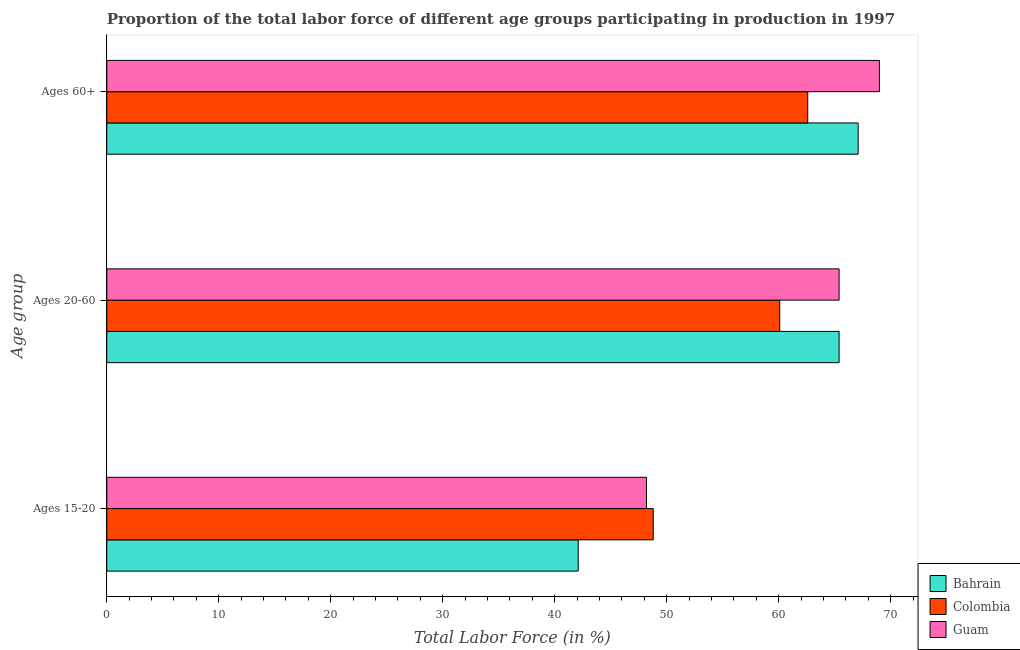How many different coloured bars are there?
Offer a terse response. 3. Are the number of bars per tick equal to the number of legend labels?
Keep it short and to the point. Yes. What is the label of the 3rd group of bars from the top?
Your response must be concise. Ages 15-20. What is the percentage of labor force within the age group 20-60 in Colombia?
Offer a very short reply. 60.1. Across all countries, what is the maximum percentage of labor force within the age group 20-60?
Provide a short and direct response. 65.4. Across all countries, what is the minimum percentage of labor force within the age group 15-20?
Ensure brevity in your answer.  42.1. In which country was the percentage of labor force within the age group 20-60 maximum?
Provide a succinct answer. Bahrain. What is the total percentage of labor force within the age group 20-60 in the graph?
Give a very brief answer. 190.9. What is the difference between the percentage of labor force within the age group 15-20 in Bahrain and that in Colombia?
Make the answer very short. -6.7. What is the difference between the percentage of labor force within the age group 20-60 in Bahrain and the percentage of labor force above age 60 in Guam?
Offer a very short reply. -3.6. What is the average percentage of labor force above age 60 per country?
Give a very brief answer. 66.23. What is the difference between the percentage of labor force above age 60 and percentage of labor force within the age group 15-20 in Bahrain?
Provide a succinct answer. 25. What is the ratio of the percentage of labor force above age 60 in Bahrain to that in Colombia?
Offer a very short reply. 1.07. Is the difference between the percentage of labor force above age 60 in Colombia and Bahrain greater than the difference between the percentage of labor force within the age group 15-20 in Colombia and Bahrain?
Provide a short and direct response. No. What is the difference between the highest and the second highest percentage of labor force above age 60?
Your response must be concise. 1.9. What is the difference between the highest and the lowest percentage of labor force above age 60?
Provide a succinct answer. 6.4. Is the sum of the percentage of labor force within the age group 20-60 in Colombia and Bahrain greater than the maximum percentage of labor force above age 60 across all countries?
Ensure brevity in your answer.  Yes. What does the 1st bar from the top in Ages 20-60 represents?
Your answer should be compact. Guam. What does the 1st bar from the bottom in Ages 20-60 represents?
Your answer should be compact. Bahrain. Is it the case that in every country, the sum of the percentage of labor force within the age group 15-20 and percentage of labor force within the age group 20-60 is greater than the percentage of labor force above age 60?
Offer a very short reply. Yes. How many bars are there?
Offer a terse response. 9. Are all the bars in the graph horizontal?
Provide a short and direct response. Yes. How many countries are there in the graph?
Offer a very short reply. 3. What is the difference between two consecutive major ticks on the X-axis?
Ensure brevity in your answer.  10. Where does the legend appear in the graph?
Ensure brevity in your answer.  Bottom right. How many legend labels are there?
Provide a short and direct response. 3. How are the legend labels stacked?
Give a very brief answer. Vertical. What is the title of the graph?
Offer a terse response. Proportion of the total labor force of different age groups participating in production in 1997. What is the label or title of the Y-axis?
Make the answer very short. Age group. What is the Total Labor Force (in %) of Bahrain in Ages 15-20?
Keep it short and to the point. 42.1. What is the Total Labor Force (in %) in Colombia in Ages 15-20?
Give a very brief answer. 48.8. What is the Total Labor Force (in %) in Guam in Ages 15-20?
Provide a succinct answer. 48.2. What is the Total Labor Force (in %) in Bahrain in Ages 20-60?
Keep it short and to the point. 65.4. What is the Total Labor Force (in %) in Colombia in Ages 20-60?
Ensure brevity in your answer.  60.1. What is the Total Labor Force (in %) of Guam in Ages 20-60?
Your answer should be compact. 65.4. What is the Total Labor Force (in %) of Bahrain in Ages 60+?
Offer a very short reply. 67.1. What is the Total Labor Force (in %) of Colombia in Ages 60+?
Make the answer very short. 62.6. Across all Age group, what is the maximum Total Labor Force (in %) of Bahrain?
Provide a short and direct response. 67.1. Across all Age group, what is the maximum Total Labor Force (in %) of Colombia?
Keep it short and to the point. 62.6. Across all Age group, what is the minimum Total Labor Force (in %) of Bahrain?
Keep it short and to the point. 42.1. Across all Age group, what is the minimum Total Labor Force (in %) in Colombia?
Offer a terse response. 48.8. Across all Age group, what is the minimum Total Labor Force (in %) in Guam?
Your answer should be very brief. 48.2. What is the total Total Labor Force (in %) of Bahrain in the graph?
Provide a succinct answer. 174.6. What is the total Total Labor Force (in %) of Colombia in the graph?
Provide a short and direct response. 171.5. What is the total Total Labor Force (in %) in Guam in the graph?
Ensure brevity in your answer.  182.6. What is the difference between the Total Labor Force (in %) of Bahrain in Ages 15-20 and that in Ages 20-60?
Offer a terse response. -23.3. What is the difference between the Total Labor Force (in %) of Colombia in Ages 15-20 and that in Ages 20-60?
Offer a terse response. -11.3. What is the difference between the Total Labor Force (in %) in Guam in Ages 15-20 and that in Ages 20-60?
Make the answer very short. -17.2. What is the difference between the Total Labor Force (in %) of Guam in Ages 15-20 and that in Ages 60+?
Your answer should be very brief. -20.8. What is the difference between the Total Labor Force (in %) of Bahrain in Ages 20-60 and that in Ages 60+?
Make the answer very short. -1.7. What is the difference between the Total Labor Force (in %) in Colombia in Ages 20-60 and that in Ages 60+?
Provide a succinct answer. -2.5. What is the difference between the Total Labor Force (in %) of Bahrain in Ages 15-20 and the Total Labor Force (in %) of Guam in Ages 20-60?
Your response must be concise. -23.3. What is the difference between the Total Labor Force (in %) of Colombia in Ages 15-20 and the Total Labor Force (in %) of Guam in Ages 20-60?
Ensure brevity in your answer.  -16.6. What is the difference between the Total Labor Force (in %) in Bahrain in Ages 15-20 and the Total Labor Force (in %) in Colombia in Ages 60+?
Offer a very short reply. -20.5. What is the difference between the Total Labor Force (in %) of Bahrain in Ages 15-20 and the Total Labor Force (in %) of Guam in Ages 60+?
Keep it short and to the point. -26.9. What is the difference between the Total Labor Force (in %) of Colombia in Ages 15-20 and the Total Labor Force (in %) of Guam in Ages 60+?
Your answer should be very brief. -20.2. What is the difference between the Total Labor Force (in %) in Colombia in Ages 20-60 and the Total Labor Force (in %) in Guam in Ages 60+?
Your response must be concise. -8.9. What is the average Total Labor Force (in %) of Bahrain per Age group?
Your response must be concise. 58.2. What is the average Total Labor Force (in %) of Colombia per Age group?
Your response must be concise. 57.17. What is the average Total Labor Force (in %) in Guam per Age group?
Make the answer very short. 60.87. What is the difference between the Total Labor Force (in %) of Bahrain and Total Labor Force (in %) of Guam in Ages 20-60?
Offer a terse response. 0. What is the difference between the Total Labor Force (in %) in Colombia and Total Labor Force (in %) in Guam in Ages 20-60?
Keep it short and to the point. -5.3. What is the difference between the Total Labor Force (in %) of Colombia and Total Labor Force (in %) of Guam in Ages 60+?
Offer a terse response. -6.4. What is the ratio of the Total Labor Force (in %) in Bahrain in Ages 15-20 to that in Ages 20-60?
Make the answer very short. 0.64. What is the ratio of the Total Labor Force (in %) in Colombia in Ages 15-20 to that in Ages 20-60?
Offer a terse response. 0.81. What is the ratio of the Total Labor Force (in %) in Guam in Ages 15-20 to that in Ages 20-60?
Keep it short and to the point. 0.74. What is the ratio of the Total Labor Force (in %) of Bahrain in Ages 15-20 to that in Ages 60+?
Provide a succinct answer. 0.63. What is the ratio of the Total Labor Force (in %) of Colombia in Ages 15-20 to that in Ages 60+?
Ensure brevity in your answer.  0.78. What is the ratio of the Total Labor Force (in %) in Guam in Ages 15-20 to that in Ages 60+?
Offer a very short reply. 0.7. What is the ratio of the Total Labor Force (in %) of Bahrain in Ages 20-60 to that in Ages 60+?
Provide a short and direct response. 0.97. What is the ratio of the Total Labor Force (in %) of Colombia in Ages 20-60 to that in Ages 60+?
Give a very brief answer. 0.96. What is the ratio of the Total Labor Force (in %) in Guam in Ages 20-60 to that in Ages 60+?
Keep it short and to the point. 0.95. What is the difference between the highest and the second highest Total Labor Force (in %) of Guam?
Your response must be concise. 3.6. What is the difference between the highest and the lowest Total Labor Force (in %) of Guam?
Give a very brief answer. 20.8. 